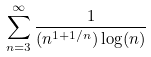Convert formula to latex. <formula><loc_0><loc_0><loc_500><loc_500>\sum _ { n = 3 } ^ { \infty } \frac { 1 } { ( n ^ { 1 + 1 / n } ) \log ( n ) }</formula> 